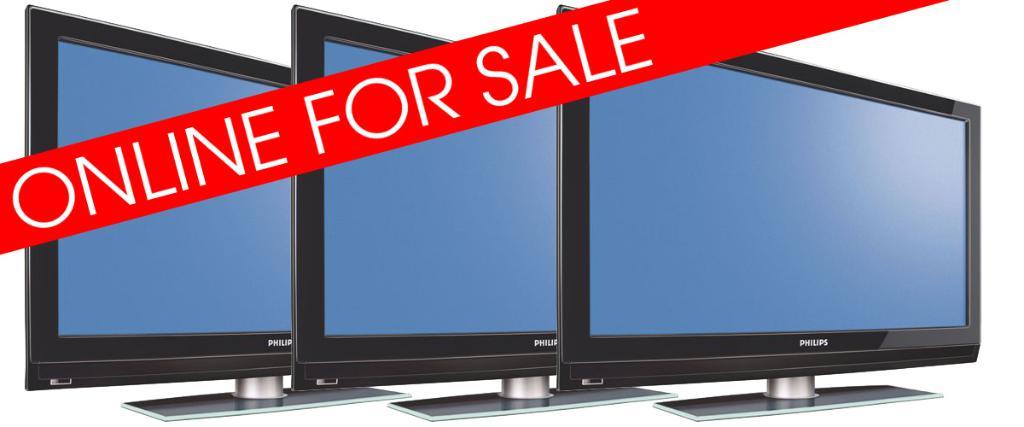Where can you purchase the tv?
Keep it short and to the point. Online. 